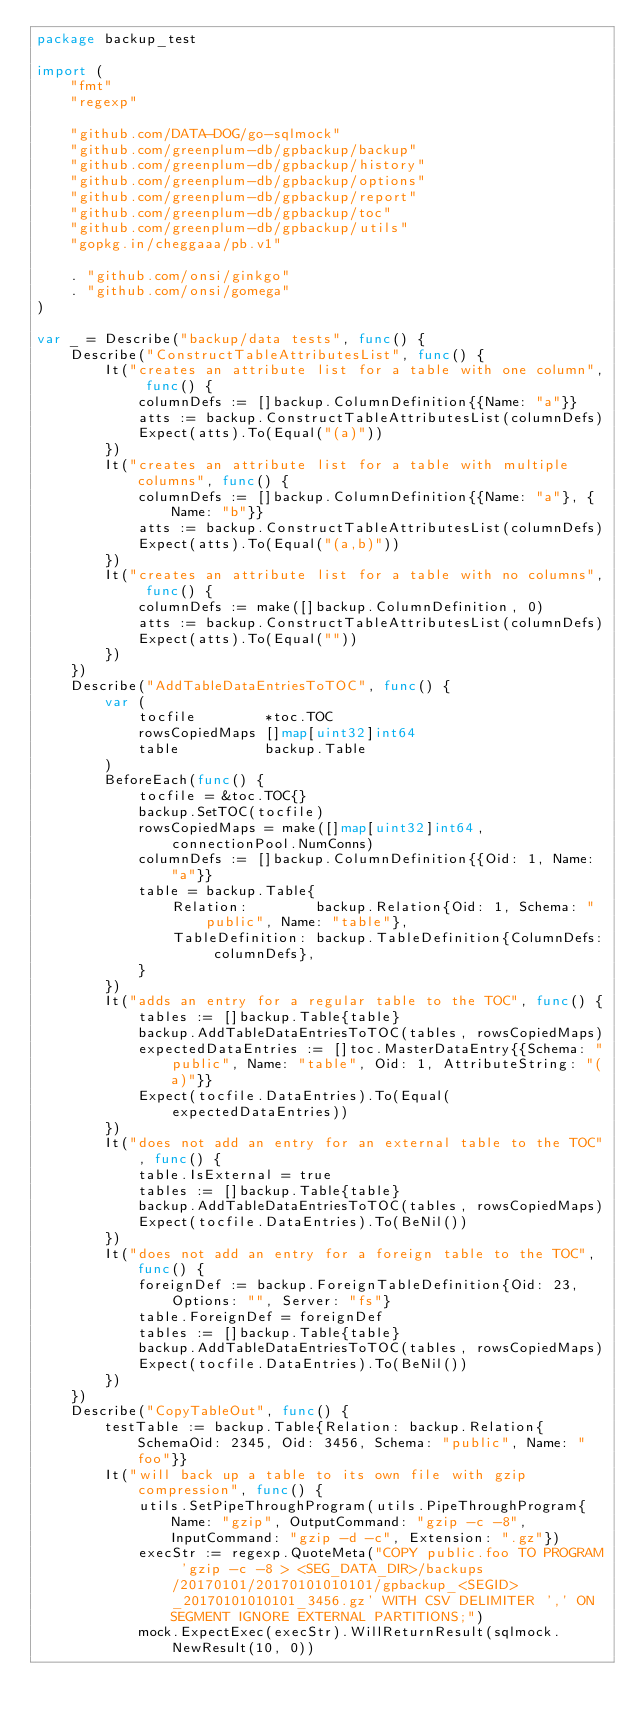Convert code to text. <code><loc_0><loc_0><loc_500><loc_500><_Go_>package backup_test

import (
	"fmt"
	"regexp"

	"github.com/DATA-DOG/go-sqlmock"
	"github.com/greenplum-db/gpbackup/backup"
	"github.com/greenplum-db/gpbackup/history"
	"github.com/greenplum-db/gpbackup/options"
	"github.com/greenplum-db/gpbackup/report"
	"github.com/greenplum-db/gpbackup/toc"
	"github.com/greenplum-db/gpbackup/utils"
	"gopkg.in/cheggaaa/pb.v1"

	. "github.com/onsi/ginkgo"
	. "github.com/onsi/gomega"
)

var _ = Describe("backup/data tests", func() {
	Describe("ConstructTableAttributesList", func() {
		It("creates an attribute list for a table with one column", func() {
			columnDefs := []backup.ColumnDefinition{{Name: "a"}}
			atts := backup.ConstructTableAttributesList(columnDefs)
			Expect(atts).To(Equal("(a)"))
		})
		It("creates an attribute list for a table with multiple columns", func() {
			columnDefs := []backup.ColumnDefinition{{Name: "a"}, {Name: "b"}}
			atts := backup.ConstructTableAttributesList(columnDefs)
			Expect(atts).To(Equal("(a,b)"))
		})
		It("creates an attribute list for a table with no columns", func() {
			columnDefs := make([]backup.ColumnDefinition, 0)
			atts := backup.ConstructTableAttributesList(columnDefs)
			Expect(atts).To(Equal(""))
		})
	})
	Describe("AddTableDataEntriesToTOC", func() {
		var (
			tocfile        *toc.TOC
			rowsCopiedMaps []map[uint32]int64
			table          backup.Table
		)
		BeforeEach(func() {
			tocfile = &toc.TOC{}
			backup.SetTOC(tocfile)
			rowsCopiedMaps = make([]map[uint32]int64, connectionPool.NumConns)
			columnDefs := []backup.ColumnDefinition{{Oid: 1, Name: "a"}}
			table = backup.Table{
				Relation:        backup.Relation{Oid: 1, Schema: "public", Name: "table"},
				TableDefinition: backup.TableDefinition{ColumnDefs: columnDefs},
			}
		})
		It("adds an entry for a regular table to the TOC", func() {
			tables := []backup.Table{table}
			backup.AddTableDataEntriesToTOC(tables, rowsCopiedMaps)
			expectedDataEntries := []toc.MasterDataEntry{{Schema: "public", Name: "table", Oid: 1, AttributeString: "(a)"}}
			Expect(tocfile.DataEntries).To(Equal(expectedDataEntries))
		})
		It("does not add an entry for an external table to the TOC", func() {
			table.IsExternal = true
			tables := []backup.Table{table}
			backup.AddTableDataEntriesToTOC(tables, rowsCopiedMaps)
			Expect(tocfile.DataEntries).To(BeNil())
		})
		It("does not add an entry for a foreign table to the TOC", func() {
			foreignDef := backup.ForeignTableDefinition{Oid: 23, Options: "", Server: "fs"}
			table.ForeignDef = foreignDef
			tables := []backup.Table{table}
			backup.AddTableDataEntriesToTOC(tables, rowsCopiedMaps)
			Expect(tocfile.DataEntries).To(BeNil())
		})
	})
	Describe("CopyTableOut", func() {
		testTable := backup.Table{Relation: backup.Relation{SchemaOid: 2345, Oid: 3456, Schema: "public", Name: "foo"}}
		It("will back up a table to its own file with gzip compression", func() {
			utils.SetPipeThroughProgram(utils.PipeThroughProgram{Name: "gzip", OutputCommand: "gzip -c -8", InputCommand: "gzip -d -c", Extension: ".gz"})
			execStr := regexp.QuoteMeta("COPY public.foo TO PROGRAM 'gzip -c -8 > <SEG_DATA_DIR>/backups/20170101/20170101010101/gpbackup_<SEGID>_20170101010101_3456.gz' WITH CSV DELIMITER ',' ON SEGMENT IGNORE EXTERNAL PARTITIONS;")
			mock.ExpectExec(execStr).WillReturnResult(sqlmock.NewResult(10, 0))</code> 